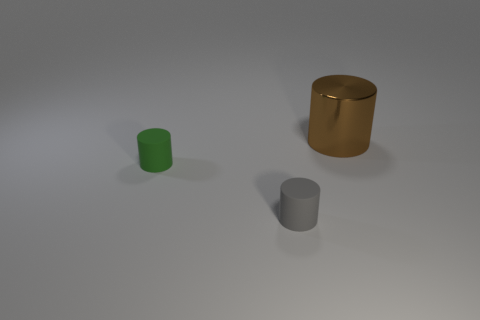What color is the tiny rubber cylinder on the left side of the matte cylinder to the right of the matte object behind the gray matte object?
Offer a terse response. Green. There is a tiny matte object that is left of the gray cylinder; what is its color?
Your answer should be very brief. Green. The thing that is the same size as the gray cylinder is what color?
Offer a very short reply. Green. Is the gray rubber thing the same size as the brown metallic thing?
Your response must be concise. No. There is a gray object; what number of big brown objects are left of it?
Provide a succinct answer. 0. What number of objects are either tiny cylinders that are in front of the tiny green cylinder or blue rubber cylinders?
Make the answer very short. 1. Is the number of gray cylinders behind the brown thing greater than the number of gray rubber objects behind the green object?
Provide a short and direct response. No. There is a brown cylinder; is it the same size as the thing in front of the tiny green cylinder?
Provide a short and direct response. No. What number of spheres are either big brown shiny objects or small yellow rubber things?
Provide a succinct answer. 0. Is the size of the cylinder to the right of the small gray rubber cylinder the same as the rubber object that is right of the green rubber thing?
Your answer should be compact. No. 